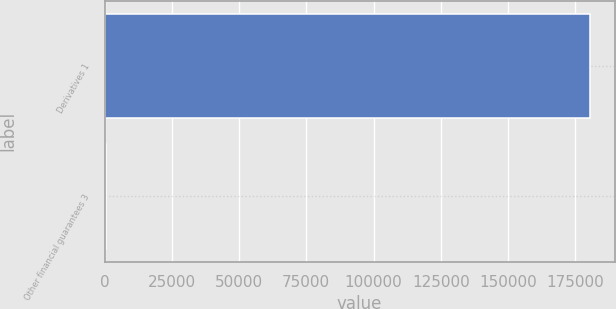Convert chart. <chart><loc_0><loc_0><loc_500><loc_500><bar_chart><fcel>Derivatives 1<fcel>Other financial guarantees 3<nl><fcel>180543<fcel>620<nl></chart> 